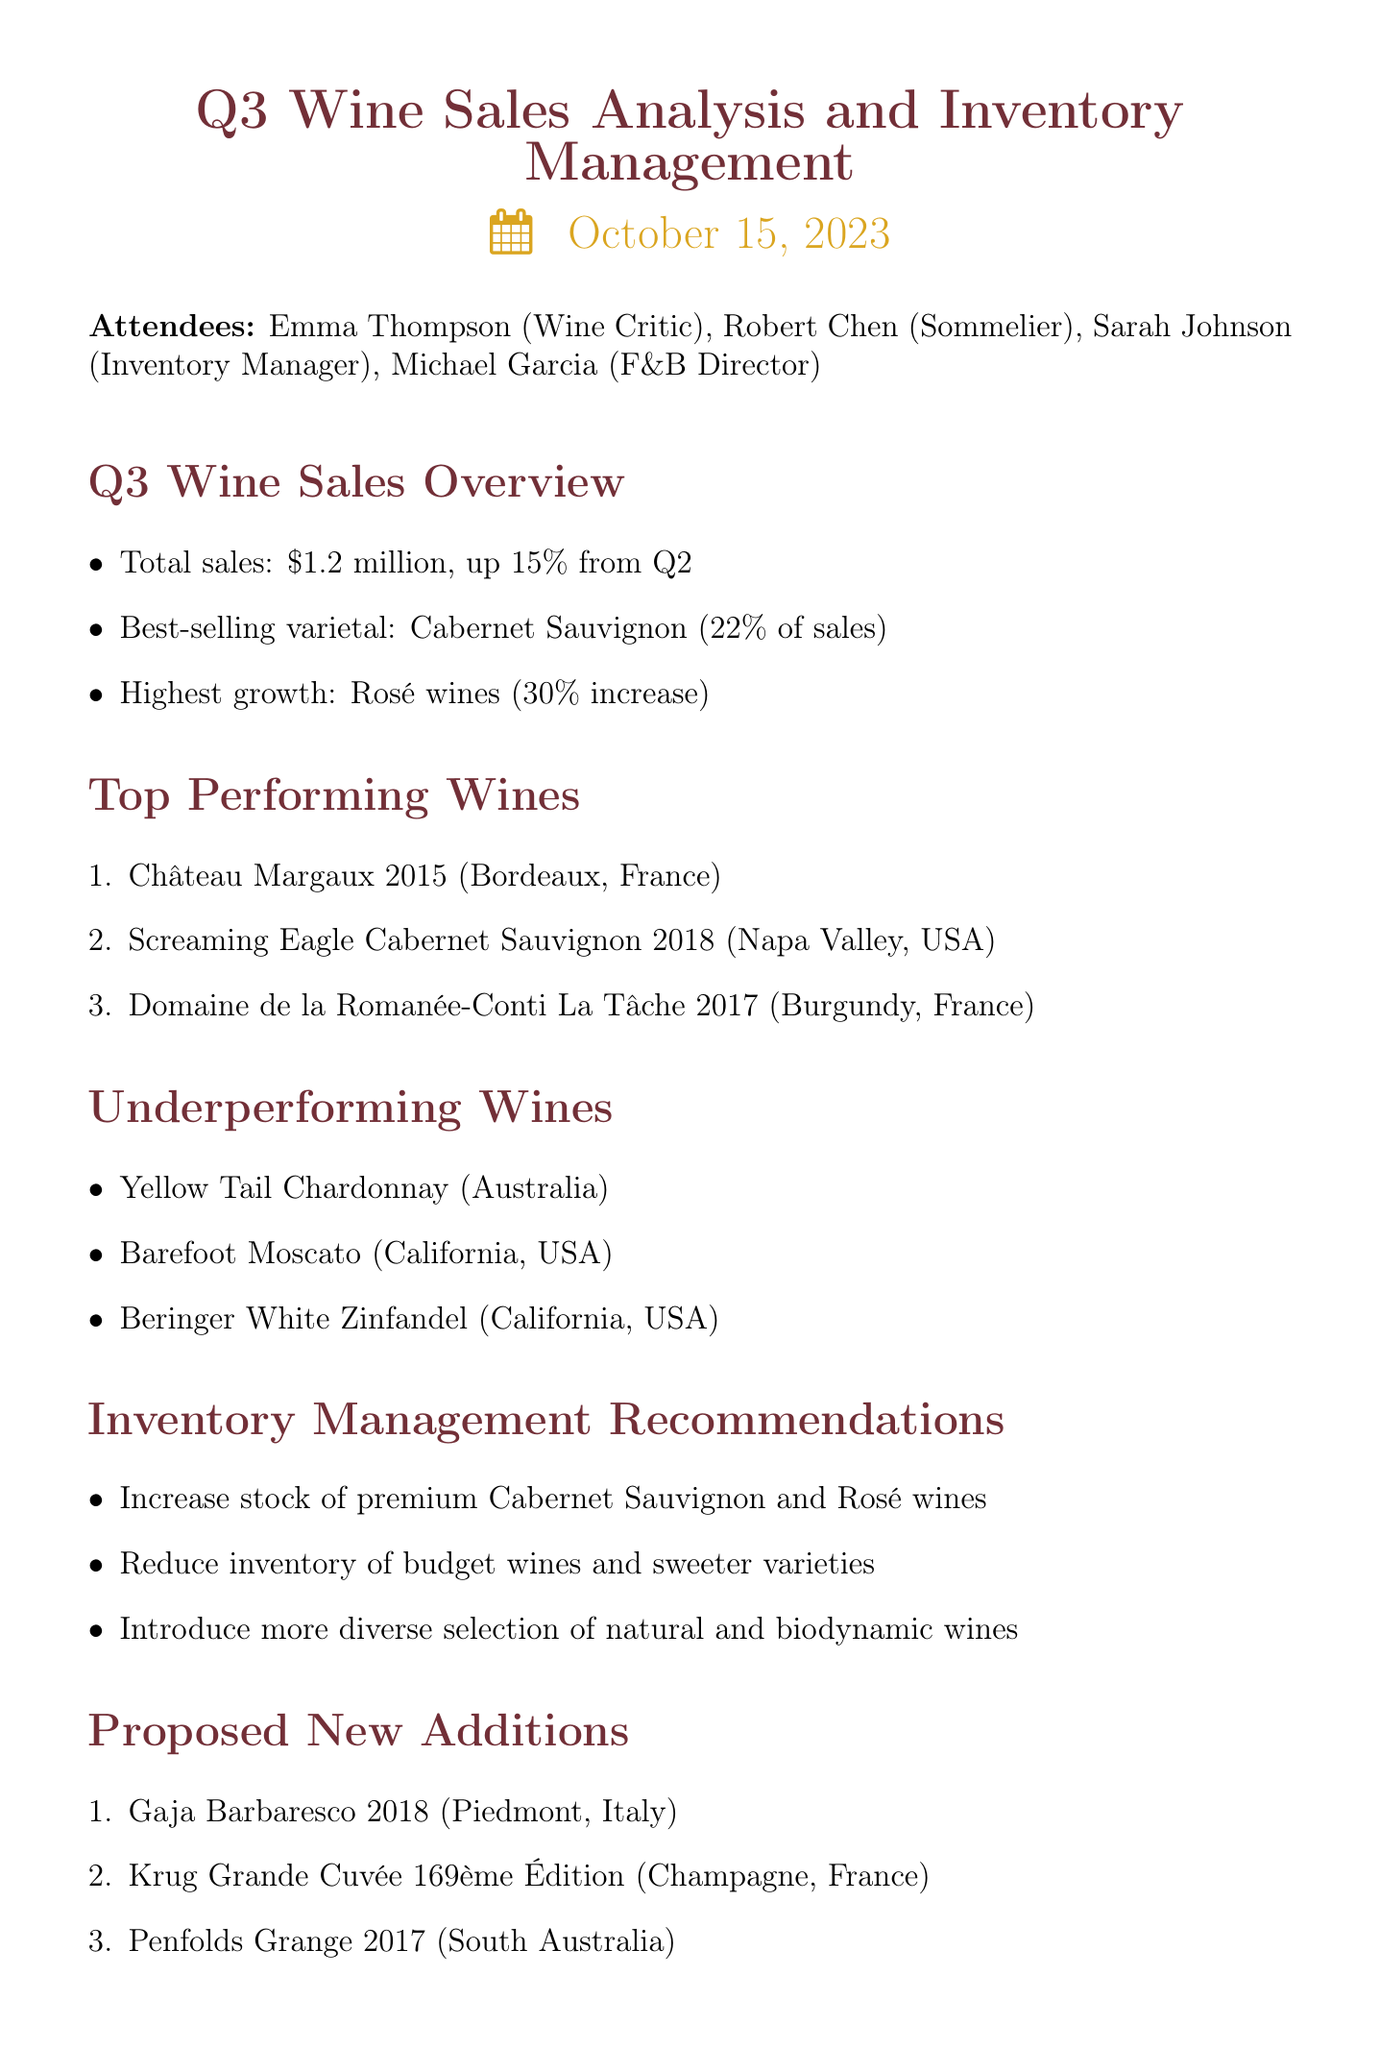What was the total sales amount for Q3? The total sales amount for Q3 is provided in the overview, which states total sales: $1.2 million.
Answer: $1.2 million Which varietal accounted for the highest percentage of sales? The details in the overview specify that the best-selling varietal was Cabernet Sauvignon, which made up 22% of sales.
Answer: Cabernet Sauvignon How much did Rosé wines increase in sales percentage? The overview indicates that Rosé wines experienced a 30% increase, reflecting their growth in the market.
Answer: 30% What are the proposed new additions to the inventory? The document lists the proposed new additions under a specific section, which includes Gaja Barbaresco 2018, Krug Grande Cuvée 169ème Édition, and Penfolds Grange 2017.
Answer: Gaja Barbaresco 2018, Krug Grande Cuvée 169ème Édition, Penfolds Grange 2017 Which wines were identified as underperforming? The underperforming wines are detailed within a specific section, stating Yellow Tail Chardonnay, Barefoot Moscato, and Beringer White Zinfandel.
Answer: Yellow Tail Chardonnay, Barefoot Moscato, Beringer White Zinfandel What action item is assigned to Emma? The action items section specifies that Emma is tasked with curating a list of 10 up-and-coming wineries.
Answer: Curate a list of 10 up-and-coming wineries Why is there a recommendation to reduce inventory of budget wines? The recommendations suggest reducing inventory of budget wines and sweeter varieties based on sales analysis indicating underperformance in those segments.
Answer: Due to underperformance in sales What trend was observed in the sales of premium wines? The document reflects an increase in sales for premium wines, particularly highlighting Cabernet Sauvignon and Rosé.
Answer: Increase in sales 